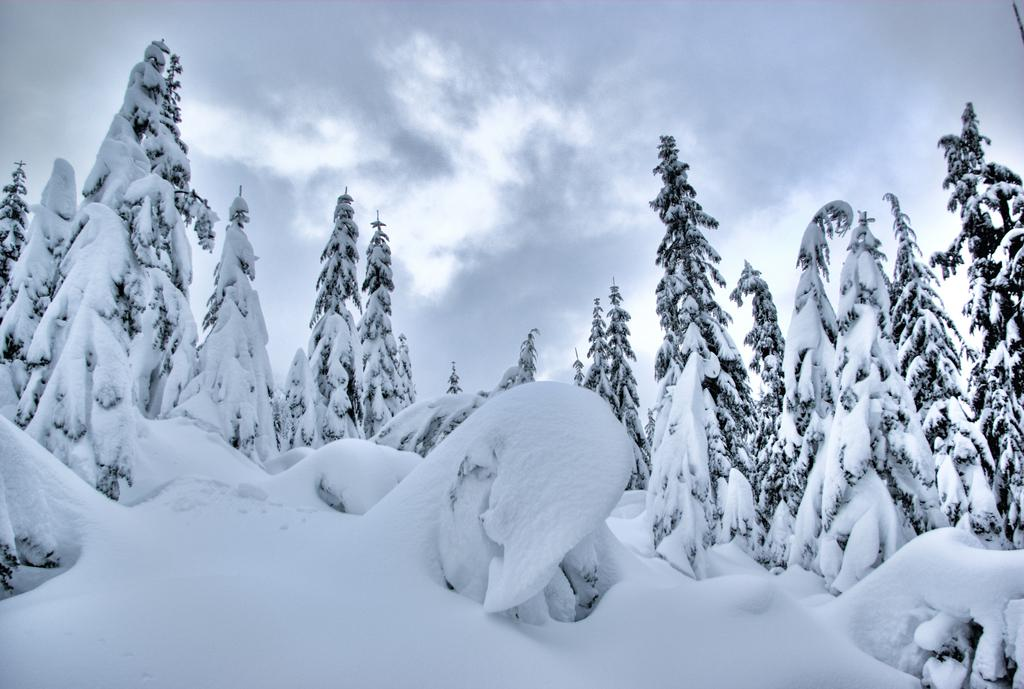What type of weather is depicted in the image? There is snow in the image, indicating cold weather. What else can be seen in the image besides snow? There are trees with snow in the image. What is visible in the background of the image? The sky is visible in the background of the image. What can be observed in the sky? Clouds are present in the sky. What type of punishment is being given to the cream in the image? There is no cream present in the image, and therefore no punishment can be observed. 